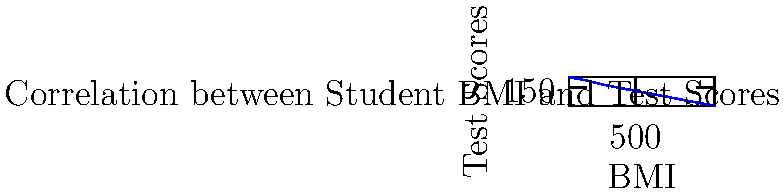As a school nurse focusing on the link between student health and academic performance, you're analyzing data on student BMI and test scores. The scatter plot shows the relationship between these two variables. What type of correlation does this data suggest, and how might this information be used to support student health and academic success? To answer this question, let's analyze the scatter plot step-by-step:

1. Observe the overall trend: As we move from left to right (increasing BMI), the points generally move downward (decreasing test scores).

2. Identify the correlation type: This pattern indicates a negative or inverse correlation between BMI and test scores.

3. Strength of correlation: The points form a fairly straight line with minimal scatter, suggesting a strong correlation.

4. Interpretation: Higher BMI values are associated with lower test scores, and vice versa.

5. Implications for student health and academic success:
   a) This data suggests that maintaining a healthy BMI might be beneficial for academic performance.
   b) Implementing health and nutrition programs could potentially improve both student health and test scores.
   c) Physical activity initiatives might help manage BMI and potentially support better academic outcomes.

6. Cautionary notes:
   a) Correlation does not imply causation. Other factors might influence both BMI and test scores.
   b) Individual cases may vary; this is a general trend across the studied population.

7. Action steps:
   a) Educate students and parents about the potential link between health and academic performance.
   b) Collaborate with teachers and administrators to promote healthy lifestyles within the school community.
   c) Monitor students' health metrics and academic performance to provide targeted support where needed.
Answer: Strong negative correlation; use to promote health initiatives for academic improvement. 